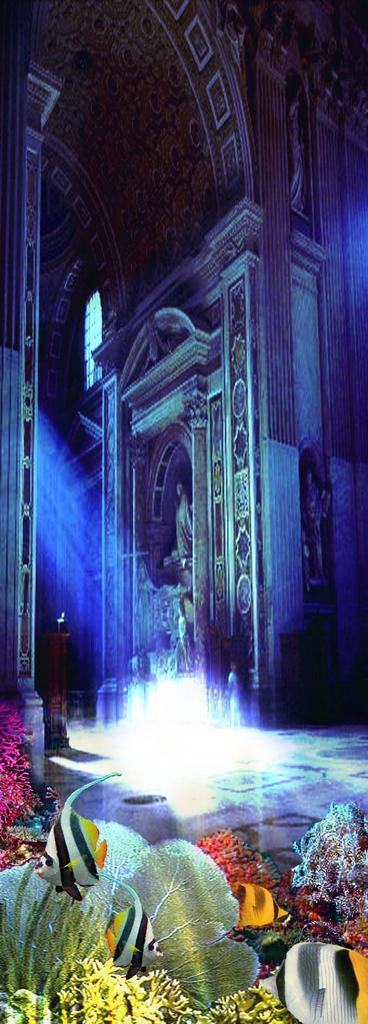What type of structure is featured in the image? There is a historical wall with sculptures in the image. What can be observed on the wall? The wall has designs on it. What additional feature is present in the image? There is an aquarium in the image. What can be found inside the aquarium? The aquarium contains fish and water plants. What type of trouble can be seen in the image? There is no indication of trouble in the image; it features a historical wall with sculptures, designs, and an aquarium with fish and water plants. 